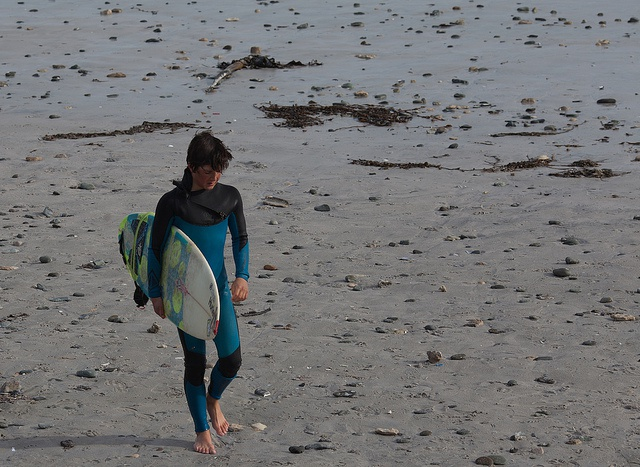Describe the objects in this image and their specific colors. I can see people in gray, black, blue, and darkblue tones and surfboard in gray, blue, black, and darkgreen tones in this image. 